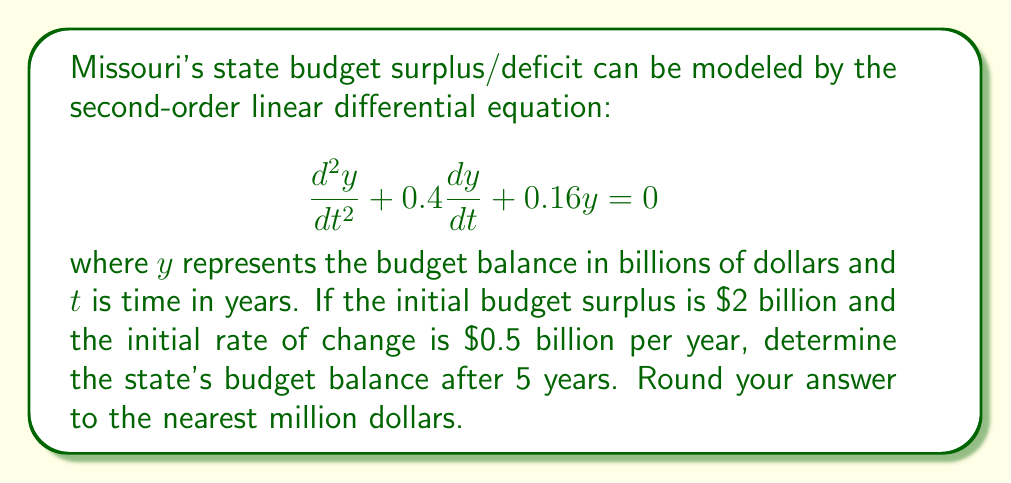Help me with this question. To solve this problem, we need to follow these steps:

1) The general solution for this second-order linear differential equation is:

   $$y = e^{-0.2t}(C_1\cos(0.4t) + C_2\sin(0.4t))$$

2) We need to find $C_1$ and $C_2$ using the initial conditions:
   
   At $t=0$, $y(0) = 2$ and $y'(0) = 0.5$

3) Using $y(0) = 2$:
   
   $$2 = C_1$$

4) Taking the derivative of the general solution:

   $$y' = -0.2e^{-0.2t}(C_1\cos(0.4t) + C_2\sin(0.4t)) + e^{-0.2t}(-0.4C_1\sin(0.4t) + 0.4C_2\cos(0.4t))$$

5) Using $y'(0) = 0.5$:

   $$0.5 = -0.2C_1 + 0.4C_2$$
   $$0.5 = -0.4 + 0.4C_2$$ (since $C_1 = 2$)
   $$C_2 = \frac{0.9}{0.4} = 2.25$$

6) Now we have the particular solution:

   $$y = e^{-0.2t}(2\cos(0.4t) + 2.25\sin(0.4t))$$

7) To find the budget balance after 5 years, we evaluate $y(5)$:

   $$y(5) = e^{-0.2(5)}(2\cos(0.4(5)) + 2.25\sin(0.4(5)))$$
   $$= e^{-1}(2\cos(2) + 2.25\sin(2))$$
   $$\approx 0.368 \times (2 \times (-0.416) + 2.25 \times 0.909)$$
   $$\approx 0.368 \times 1.212$$
   $$\approx 0.446$$

8) Converting to millions of dollars and rounding:

   $0.446$ billion = $446$ million
Answer: $446 million 